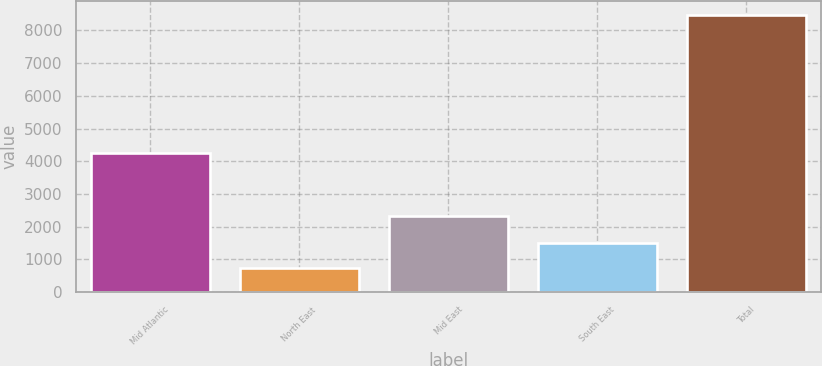Convert chart. <chart><loc_0><loc_0><loc_500><loc_500><bar_chart><fcel>Mid Atlantic<fcel>North East<fcel>Mid East<fcel>South East<fcel>Total<nl><fcel>4238<fcel>728<fcel>2335<fcel>1503.9<fcel>8487<nl></chart> 